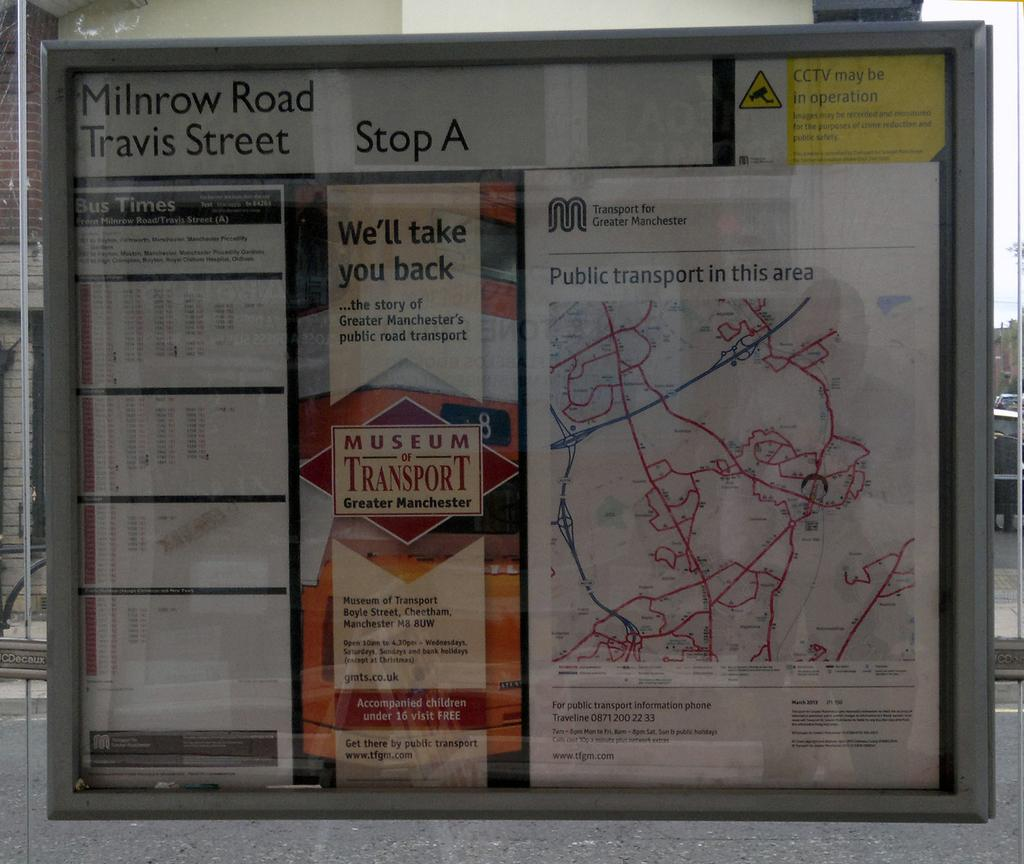<image>
Share a concise interpretation of the image provided. A transport map for the Milnrow Road area is shown. 